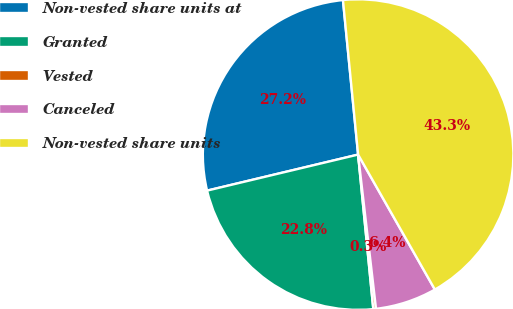Convert chart to OTSL. <chart><loc_0><loc_0><loc_500><loc_500><pie_chart><fcel>Non-vested share units at<fcel>Granted<fcel>Vested<fcel>Canceled<fcel>Non-vested share units<nl><fcel>27.17%<fcel>22.83%<fcel>0.28%<fcel>6.39%<fcel>43.32%<nl></chart> 